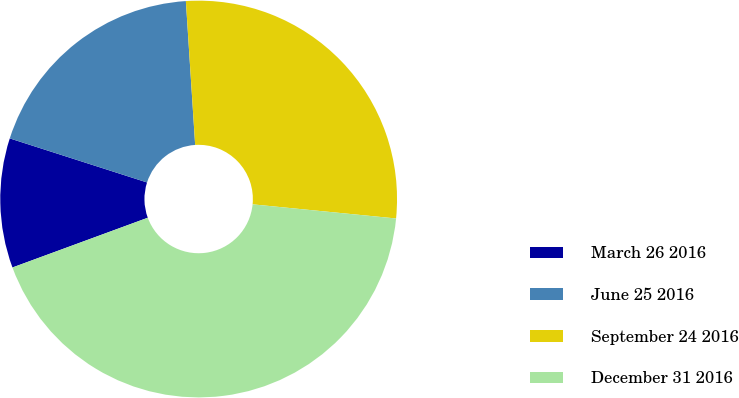Convert chart. <chart><loc_0><loc_0><loc_500><loc_500><pie_chart><fcel>March 26 2016<fcel>June 25 2016<fcel>September 24 2016<fcel>December 31 2016<nl><fcel>10.55%<fcel>19.03%<fcel>27.59%<fcel>42.83%<nl></chart> 